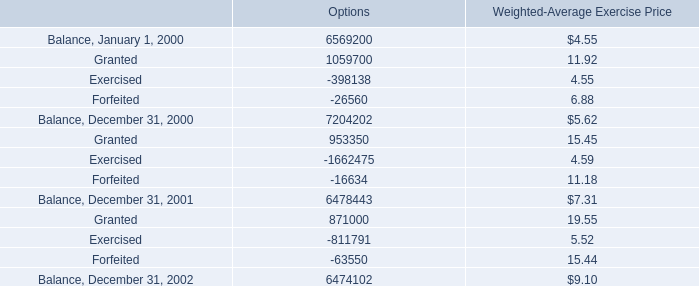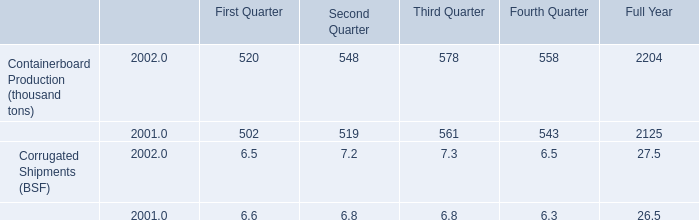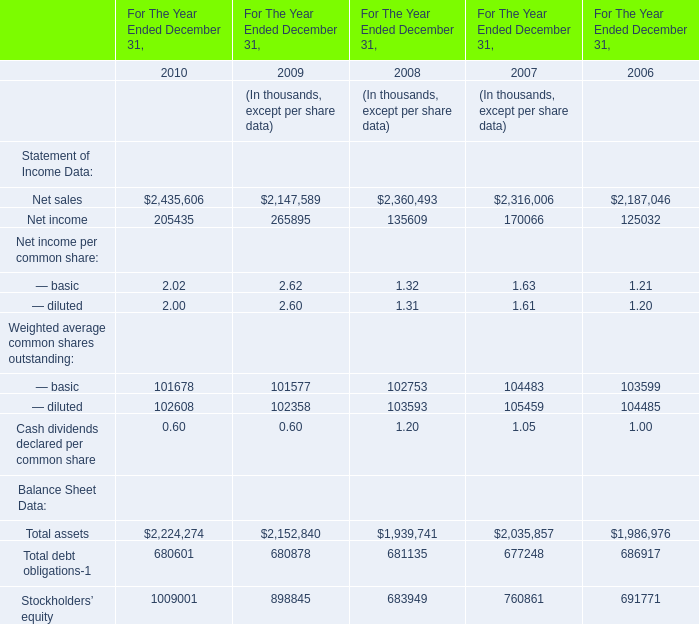What will Net income reach in 2011 if it continues to grow at its current rate? (in thousand) 
Computations: (205435 * (1 + ((205435 - 265895) / 265895)))
Answer: 158722.57555. 